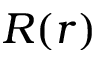Convert formula to latex. <formula><loc_0><loc_0><loc_500><loc_500>R ( r )</formula> 